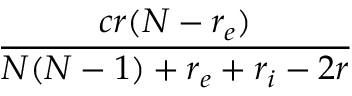<formula> <loc_0><loc_0><loc_500><loc_500>\frac { c r ( N - r _ { e } ) } { N ( N - 1 ) + r _ { e } + r _ { i } - 2 r }</formula> 